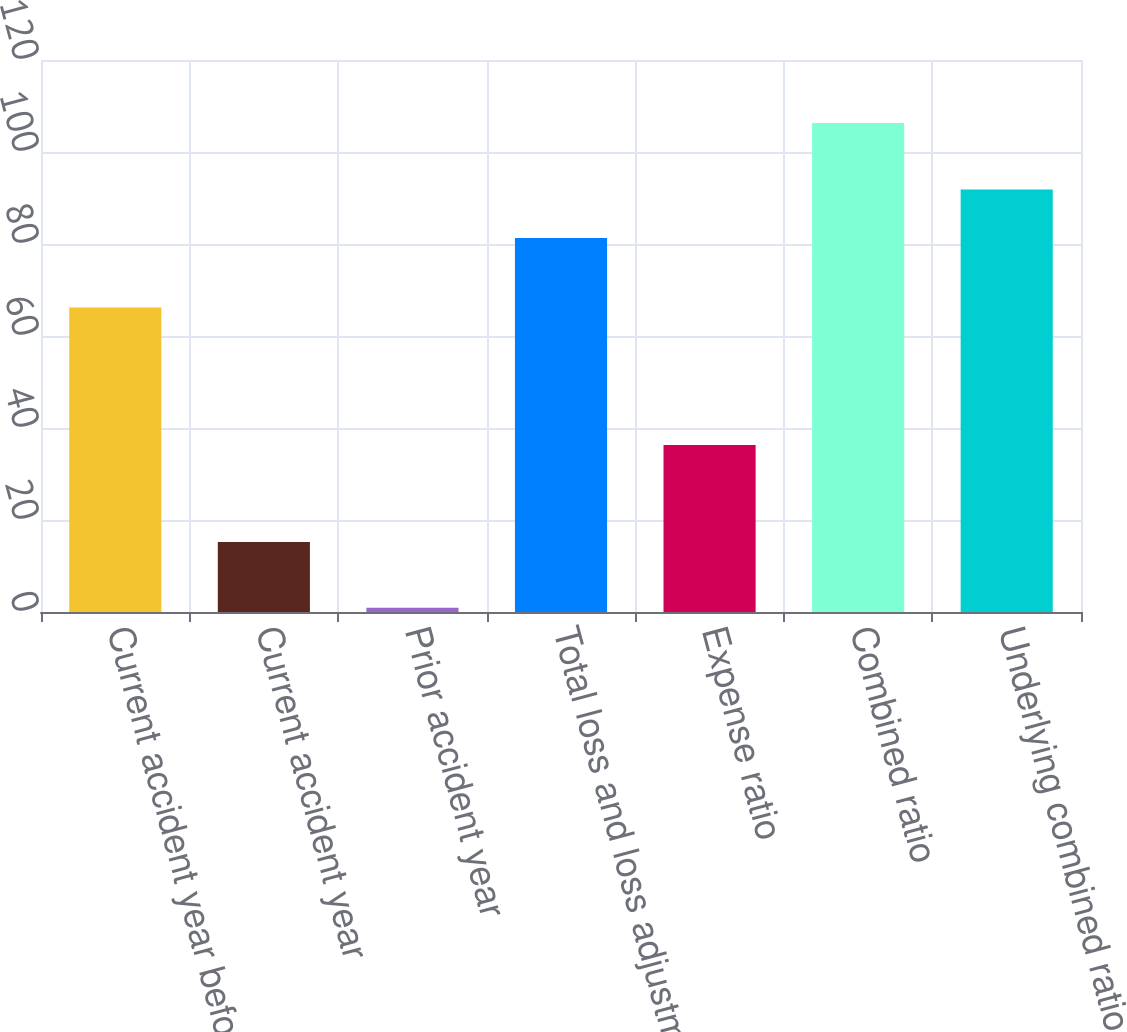<chart> <loc_0><loc_0><loc_500><loc_500><bar_chart><fcel>Current accident year before<fcel>Current accident year<fcel>Prior accident year<fcel>Total loss and loss adjustment<fcel>Expense ratio<fcel>Combined ratio<fcel>Underlying combined ratio<nl><fcel>66.2<fcel>15.2<fcel>0.9<fcel>81.3<fcel>36.28<fcel>106.3<fcel>91.84<nl></chart> 